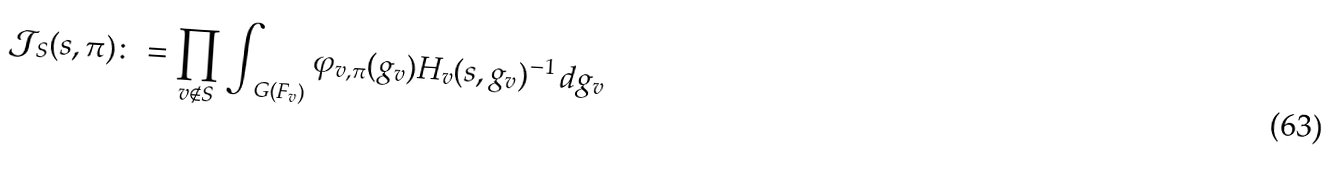Convert formula to latex. <formula><loc_0><loc_0><loc_500><loc_500>\mathcal { J } _ { S } ( { s } , \pi ) \colon = \prod _ { v \notin S } \int _ { \ G ( F _ { v } ) } \varphi _ { v , \pi } ( g _ { v } ) H _ { v } ( { s } , g _ { v } ) ^ { - 1 } \, d g _ { v }</formula> 